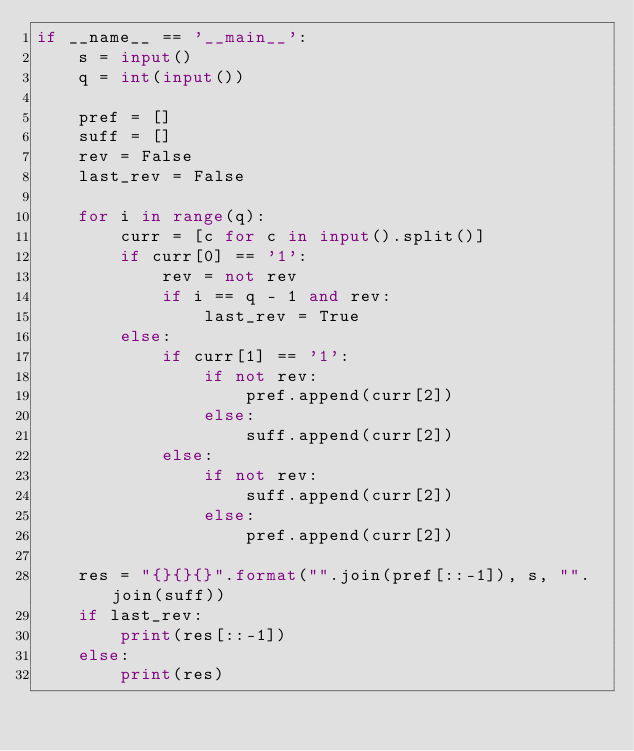Convert code to text. <code><loc_0><loc_0><loc_500><loc_500><_Python_>if __name__ == '__main__':
    s = input()
    q = int(input())

    pref = []
    suff = []
    rev = False
    last_rev = False

    for i in range(q):
        curr = [c for c in input().split()]
        if curr[0] == '1':
            rev = not rev
            if i == q - 1 and rev:
                last_rev = True
        else:
            if curr[1] == '1':
                if not rev:
                    pref.append(curr[2])
                else:
                    suff.append(curr[2])
            else:
                if not rev:
                    suff.append(curr[2])
                else:
                    pref.append(curr[2])

    res = "{}{}{}".format("".join(pref[::-1]), s, "".join(suff))
    if last_rev:
        print(res[::-1])
    else:
        print(res)
</code> 